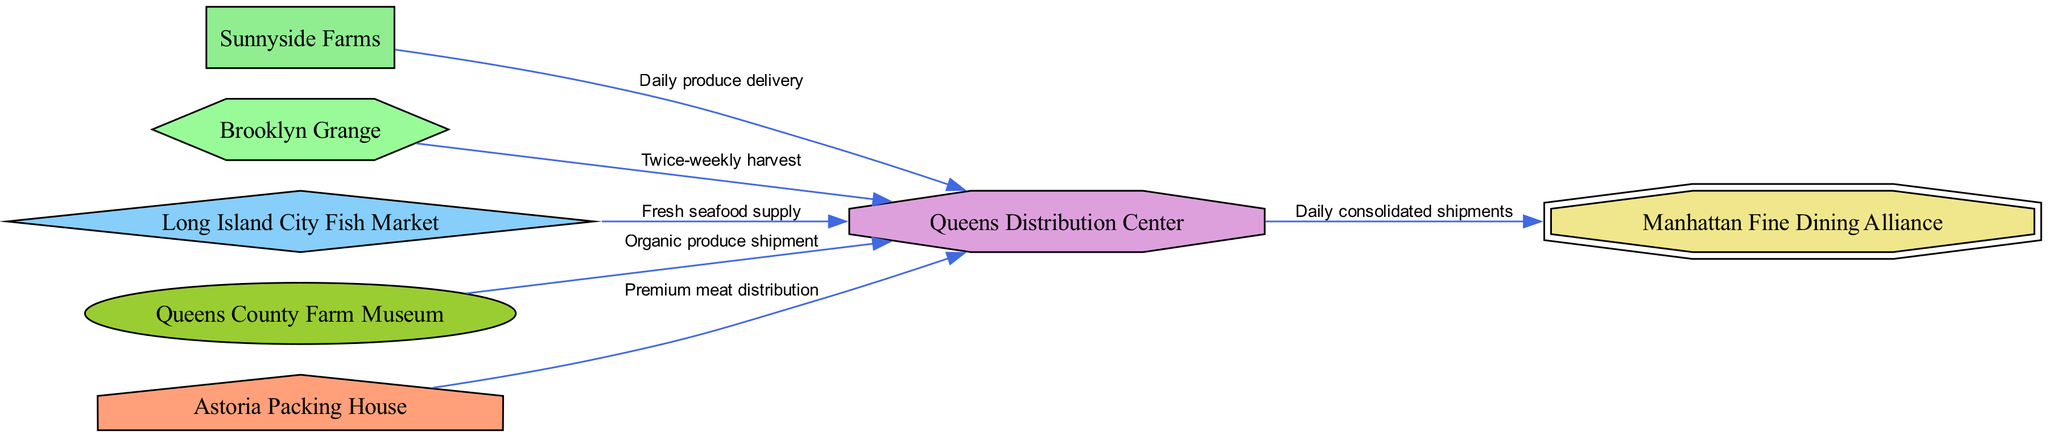What is the type of Sunnyside Farms? Sunnyside Farms is categorized as a "Local Produce Supplier" in the diagram. This can be identified by looking at the node labeled "Sunnyside Farms" and checking its associated type.
Answer: Local Produce Supplier How many local suppliers are shown in the diagram? The diagram includes five local suppliers: Sunnyside Farms, Brooklyn Grange, Long Island City Fish Market, Queens County Farm Museum, and Astoria Packing House. By counting the nodes that categorize as suppliers, we arrive at this number.
Answer: Five What is the relationship between Queens Distribution Center and Manhattan Fine Dining Alliance? The relationship is illustrated by a directed edge labeled "Daily consolidated shipments" from Queens Distribution Center to Manhattan Fine Dining Alliance. By examining the edges connected to these nodes, the relationship can be established.
Answer: Daily consolidated shipments Which supplier delivers seafood? Long Island City Fish Market is the designated seafood supplier as indicated in the diagram. The node for Long Island City Fish Market shows its type as "Seafood Supplier."
Answer: Long Island City Fish Market What type of relationship does Brooklyn Grange have with Queens Distribution Center? Brooklyn Grange has a "Twice-weekly harvest" relationship with Queens Distribution Center as depicted by the directed edge between these two nodes. There are details associated with the edge that specify the nature of this relationship.
Answer: Twice-weekly harvest How many edges connect to the Queens Distribution Center? There are five edges connecting to the Queens Distribution Center, specifically from Sunnyside Farms, Brooklyn Grange, Long Island City Fish Market, Queens County Farm Museum, and Astoria Packing House. Counting these edges gives us the total number.
Answer: Five What type of node is represented by Astoria Packing House? Astoria Packing House is classified as a "Meat Distributor" in the diagram. Looking at the node labeled "Astoria Packing House," we can see its assigned type clearly.
Answer: Meat Distributor Which local supplier has the most frequent deliveries mentioned? Sunnyside Farms is noted for "Daily produce delivery," making it the supplier with the most frequent delivery schedule. This can be deduced from the frequency mentioned in its associated edge.
Answer: Daily produce delivery 